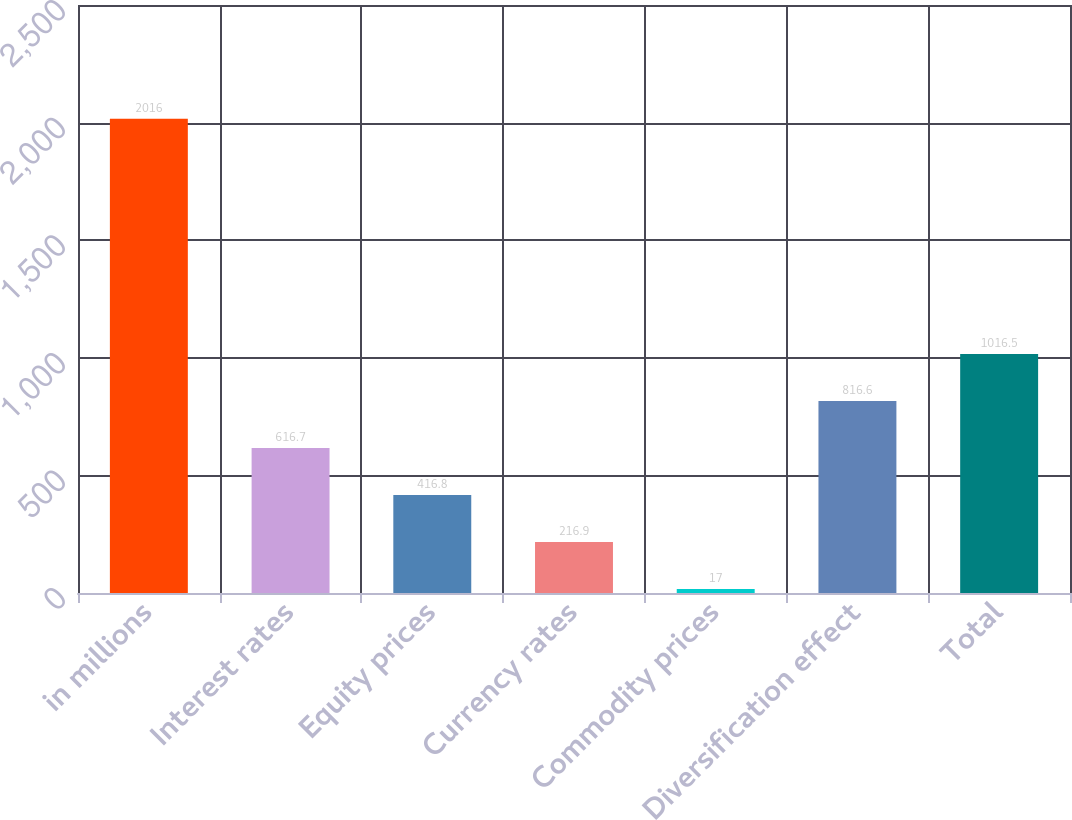Convert chart to OTSL. <chart><loc_0><loc_0><loc_500><loc_500><bar_chart><fcel>in millions<fcel>Interest rates<fcel>Equity prices<fcel>Currency rates<fcel>Commodity prices<fcel>Diversification effect<fcel>Total<nl><fcel>2016<fcel>616.7<fcel>416.8<fcel>216.9<fcel>17<fcel>816.6<fcel>1016.5<nl></chart> 